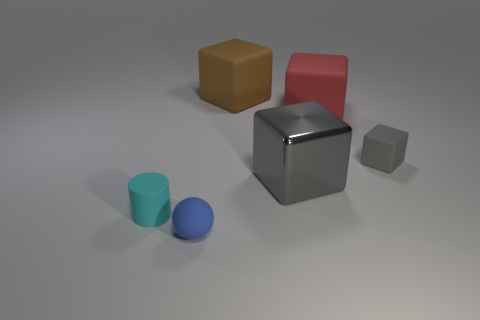Subtract all cyan cubes. Subtract all green cylinders. How many cubes are left? 4 Add 4 blue cylinders. How many objects exist? 10 Subtract all spheres. How many objects are left? 5 Add 6 tiny yellow cubes. How many tiny yellow cubes exist? 6 Subtract 0 yellow blocks. How many objects are left? 6 Subtract all rubber cubes. Subtract all cyan matte cylinders. How many objects are left? 2 Add 2 brown rubber things. How many brown rubber things are left? 3 